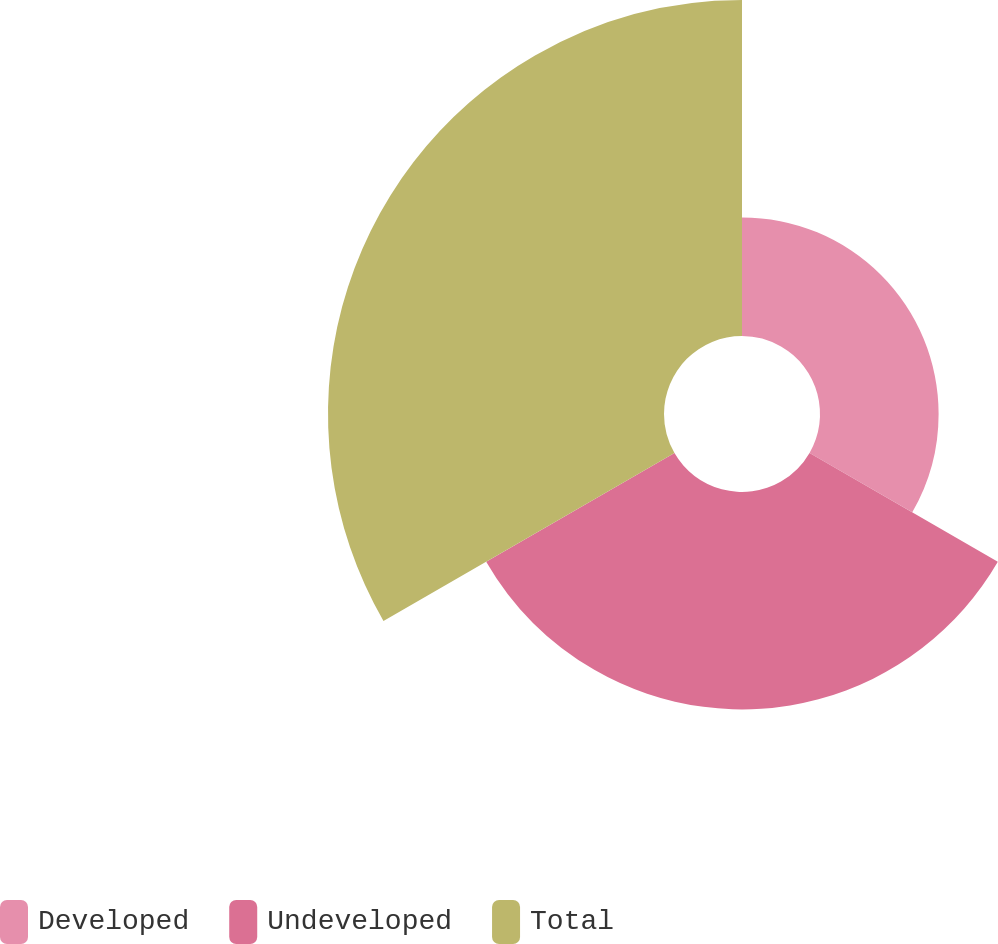<chart> <loc_0><loc_0><loc_500><loc_500><pie_chart><fcel>Developed<fcel>Undeveloped<fcel>Total<nl><fcel>17.65%<fcel>32.35%<fcel>50.0%<nl></chart> 